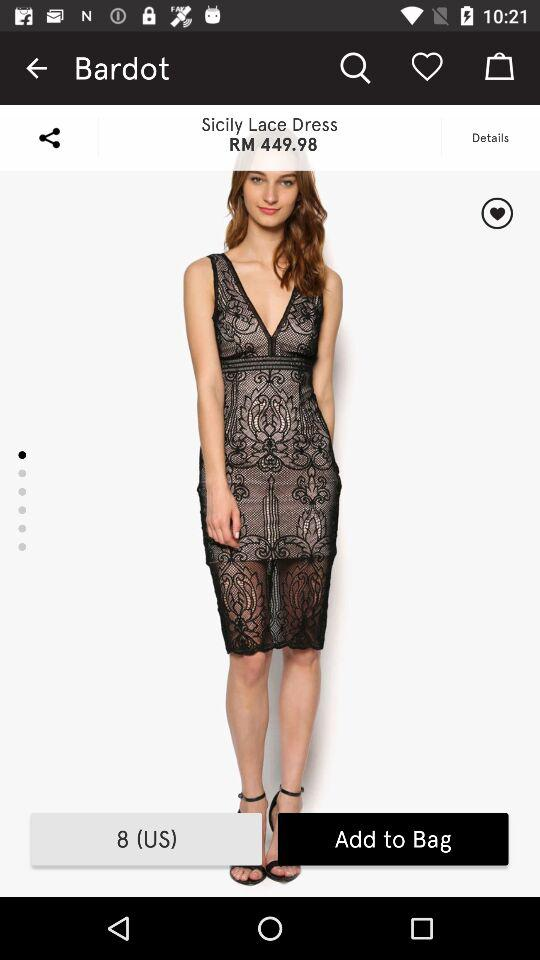What's the price of the Sicily lace dress? The price is RM 449.98. 